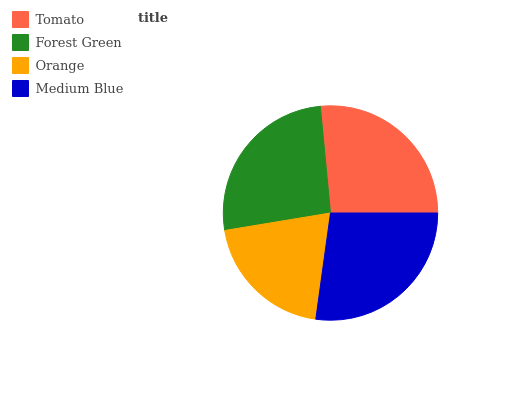Is Orange the minimum?
Answer yes or no. Yes. Is Medium Blue the maximum?
Answer yes or no. Yes. Is Forest Green the minimum?
Answer yes or no. No. Is Forest Green the maximum?
Answer yes or no. No. Is Tomato greater than Forest Green?
Answer yes or no. Yes. Is Forest Green less than Tomato?
Answer yes or no. Yes. Is Forest Green greater than Tomato?
Answer yes or no. No. Is Tomato less than Forest Green?
Answer yes or no. No. Is Tomato the high median?
Answer yes or no. Yes. Is Forest Green the low median?
Answer yes or no. Yes. Is Medium Blue the high median?
Answer yes or no. No. Is Orange the low median?
Answer yes or no. No. 